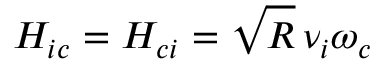Convert formula to latex. <formula><loc_0><loc_0><loc_500><loc_500>H _ { i c } = H _ { c i } = \sqrt { R } \, \nu _ { i } \omega _ { c }</formula> 